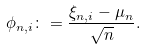<formula> <loc_0><loc_0><loc_500><loc_500>\phi _ { n , i } \colon = \frac { \xi _ { n , i } - \mu _ { n } } { \sqrt { n } } .</formula> 